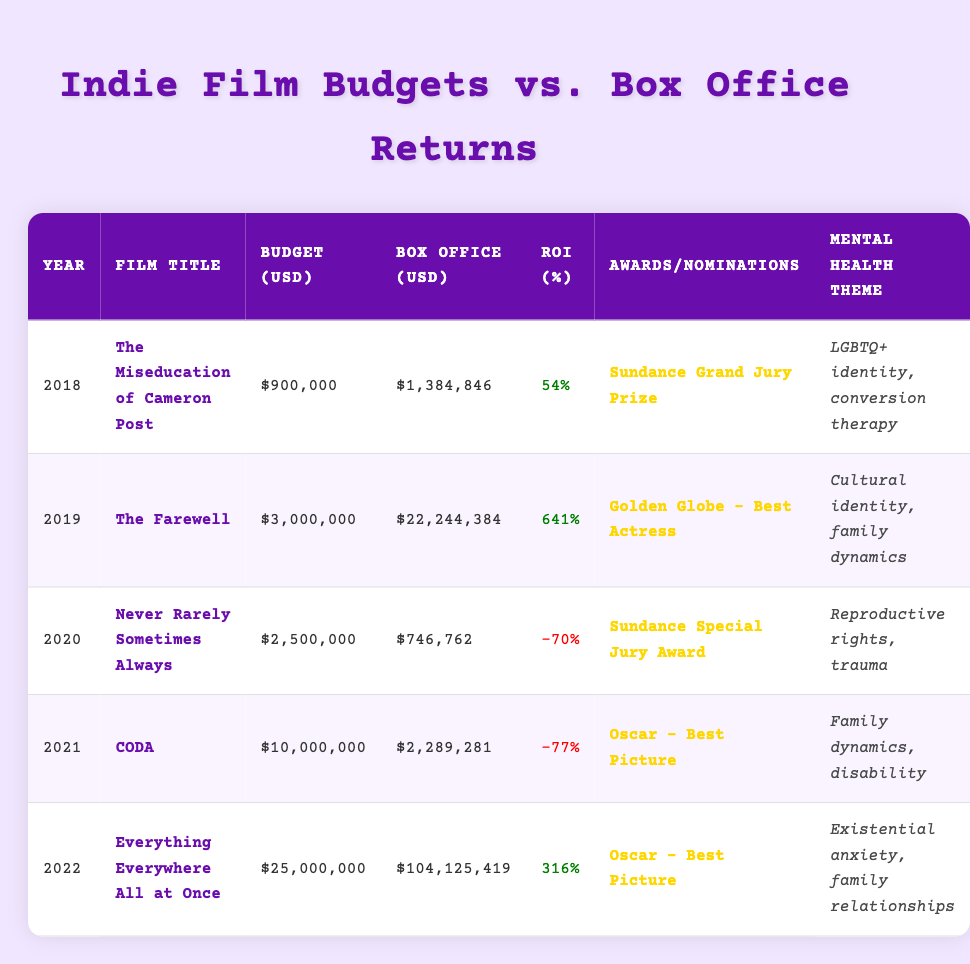What was the box office return for "CODA"? From the table, I can find the row for "CODA" under the Year 2021. The box office return listed is $2,289,281.
Answer: $2,289,281 Which film had the highest return on investment? To determine this, I look for the highest value in the ROI (%) column. "The Farewell" has the highest ROI at 641%.
Answer: 641% What was the total budget allocated for the films released in 2020 and 2021? The budgets for 2020 ("Never Rarely Sometimes Always") and 2021 ("CODA") are $2,500,000 and $10,000,000 respectively. Summing these gives $2,500,000 + $10,000,000 = $12,500,000.
Answer: $12,500,000 Did "Everything Everywhere All at Once" receive any awards or nominations? Checking the Awards/Nominations column for "Everything Everywhere All at Once," it shows that it won an Oscar for Best Picture.
Answer: Yes Is the mental health theme for "The Miseducation of Cameron Post" focused on family dynamics? The theme listed for "The Miseducation of Cameron Post" is LGBTQ+ identity and conversion therapy, not family dynamics. Therefore, this statement is false.
Answer: No How many films from the table had a negative ROI? By examining the ROI column, I find two films with negative ROI: "Never Rarely Sometimes Always" at -70% and "CODA" at -77%. That means there are two films.
Answer: 2 What is the average box office return for films with a mental health theme listed? The box office returns for the films with listed mental health themes are $1,384,846 (2018), $22,244,384 (2019), $746,762 (2020), $2,289,281 (2021), and $104,125,419 (2022). Adding these amounts gives $130,684,692. Divided by 5 films, the average is $130,684,692 / 5 = $26,136,938.4.
Answer: $26,136,938 In what year did a film based on reproductive rights get released? I check the data and find "Never Rarely Sometimes Always," which addresses reproductive rights, was released in 2020.
Answer: 2020 